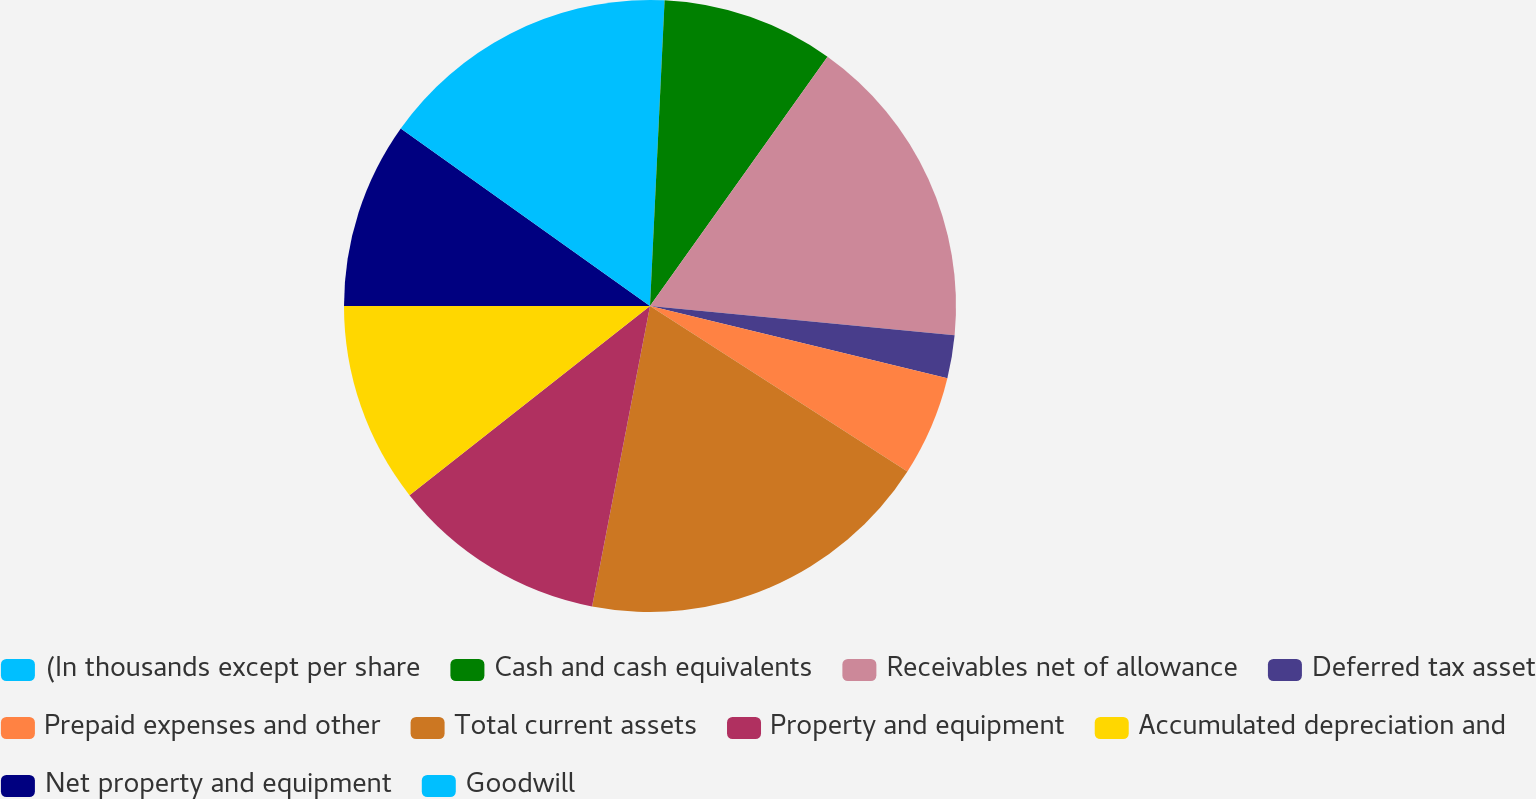<chart> <loc_0><loc_0><loc_500><loc_500><pie_chart><fcel>(In thousands except per share<fcel>Cash and cash equivalents<fcel>Receivables net of allowance<fcel>Deferred tax asset<fcel>Prepaid expenses and other<fcel>Total current assets<fcel>Property and equipment<fcel>Accumulated depreciation and<fcel>Net property and equipment<fcel>Goodwill<nl><fcel>0.76%<fcel>9.09%<fcel>16.67%<fcel>2.27%<fcel>5.3%<fcel>18.94%<fcel>11.36%<fcel>10.61%<fcel>9.85%<fcel>15.15%<nl></chart> 